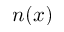Convert formula to latex. <formula><loc_0><loc_0><loc_500><loc_500>n ( x )</formula> 